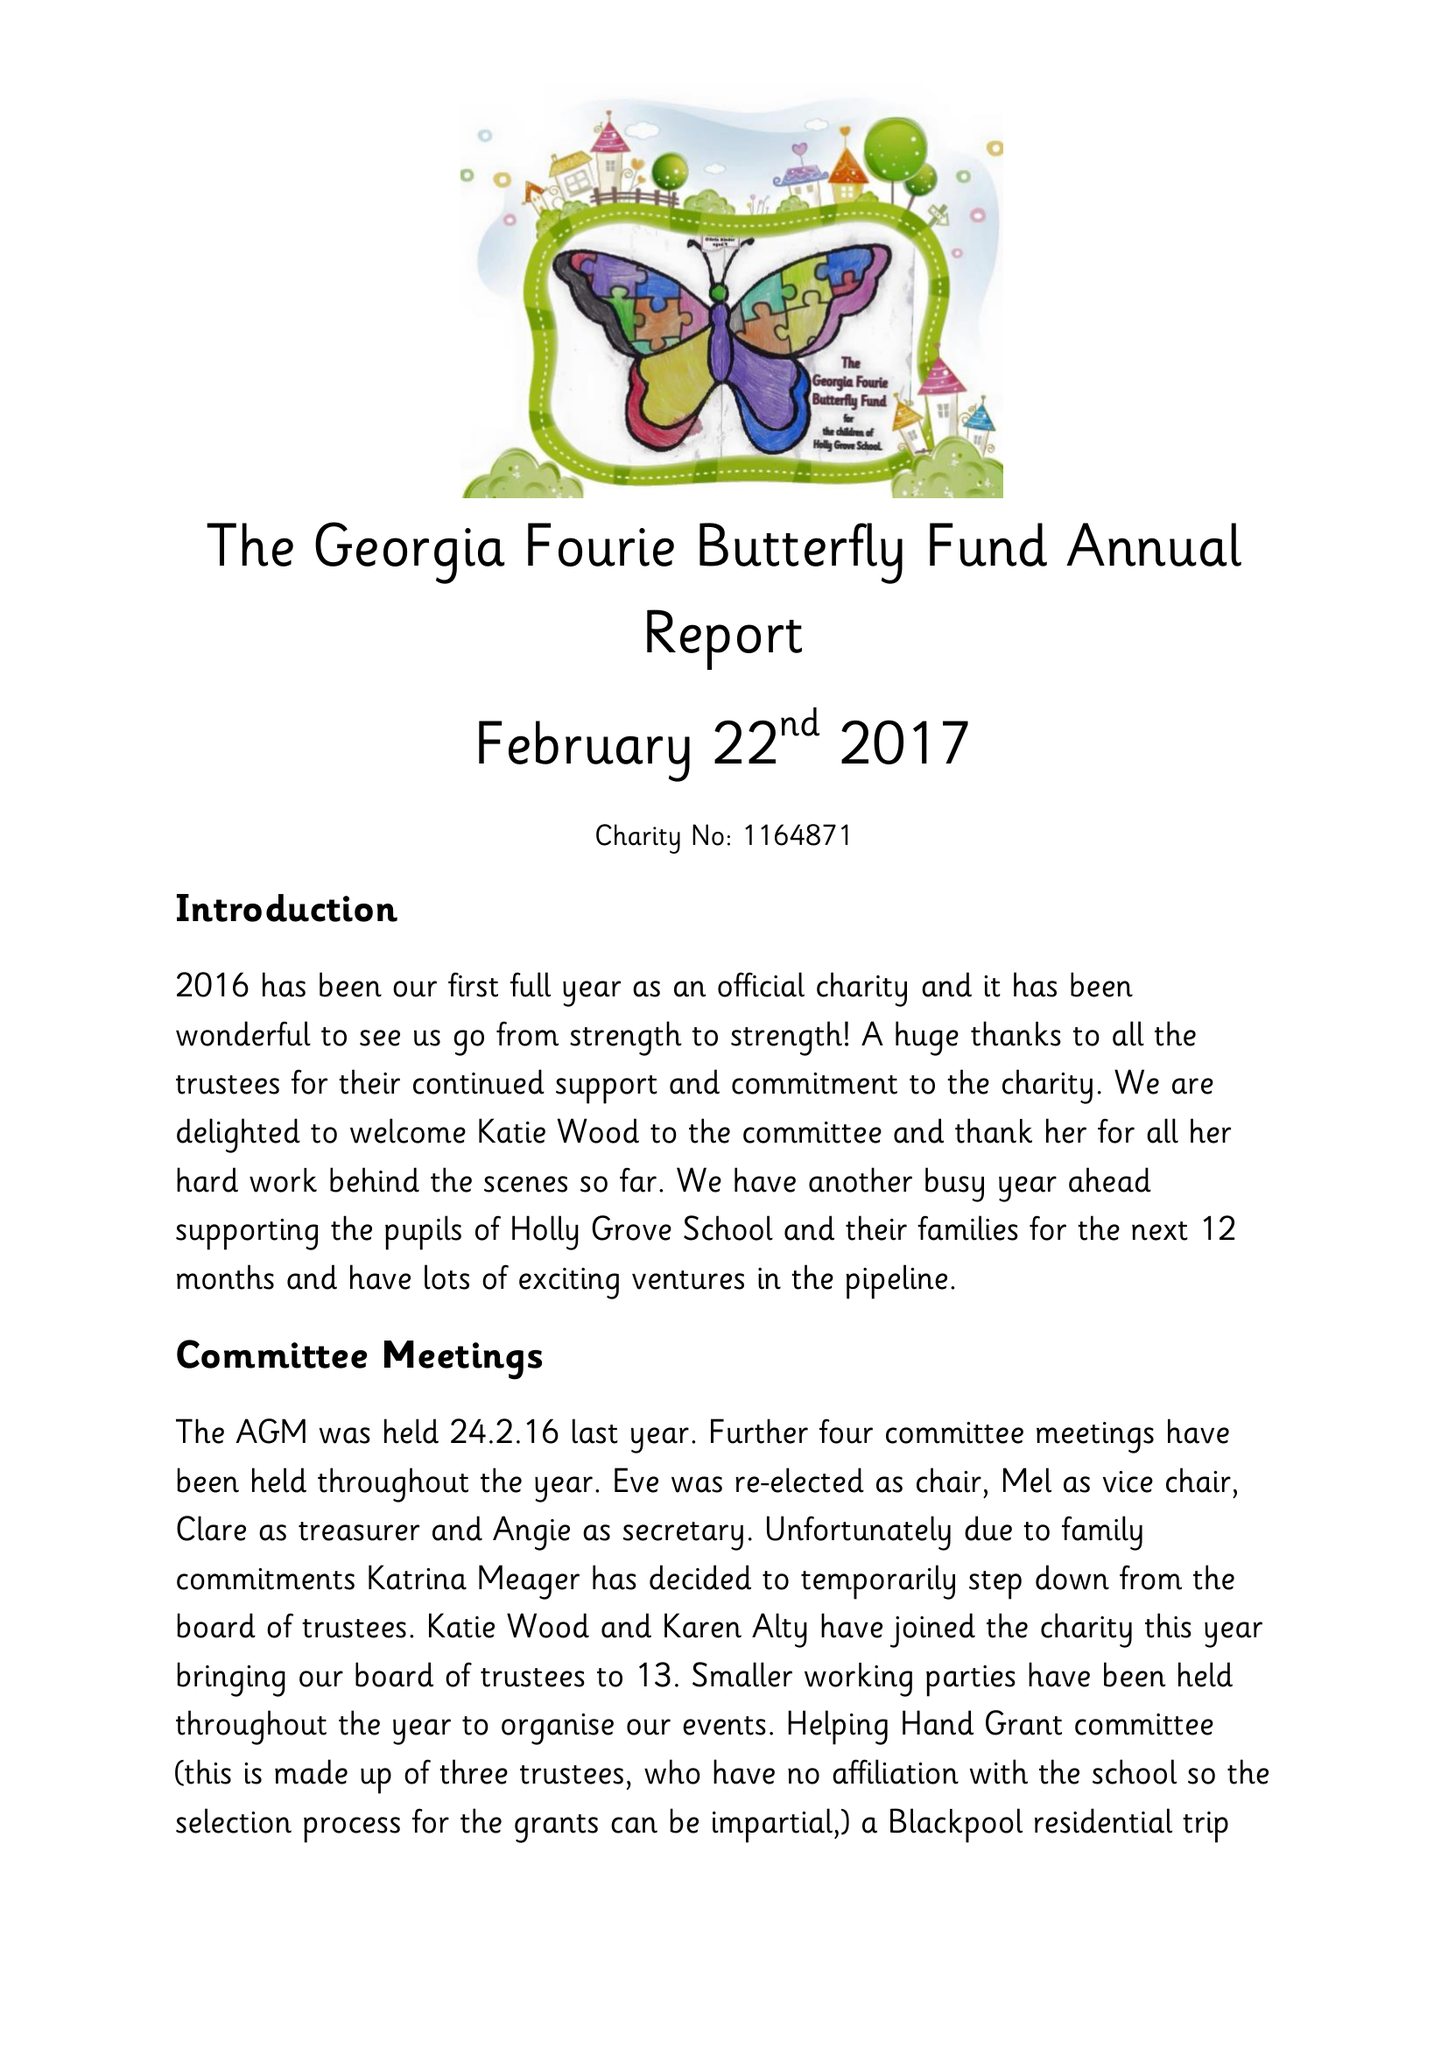What is the value for the address__post_town?
Answer the question using a single word or phrase. BURNLEY 